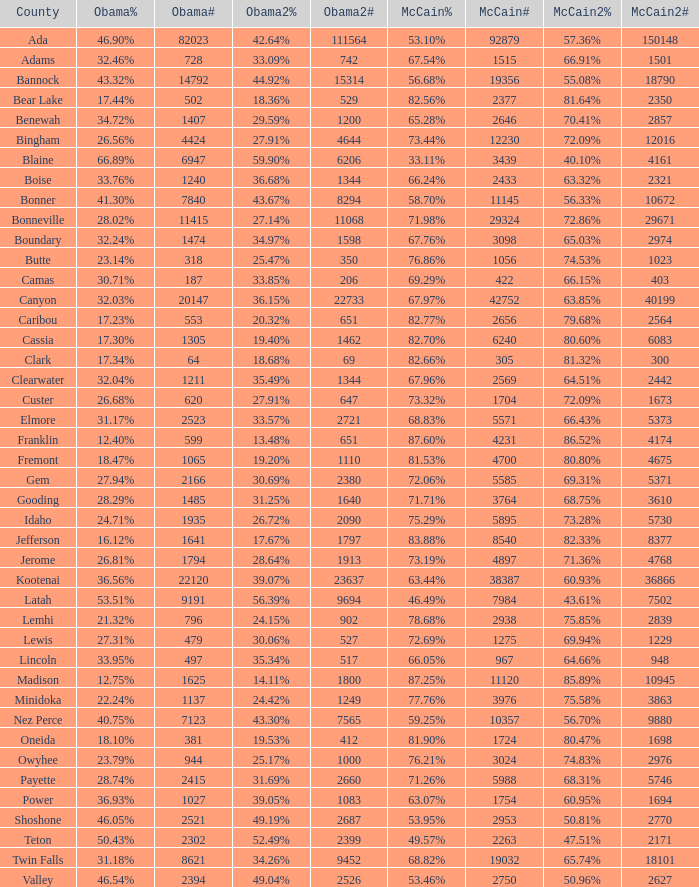What is the total number of McCain vote totals where Obama percentages was 17.34%? 1.0. 